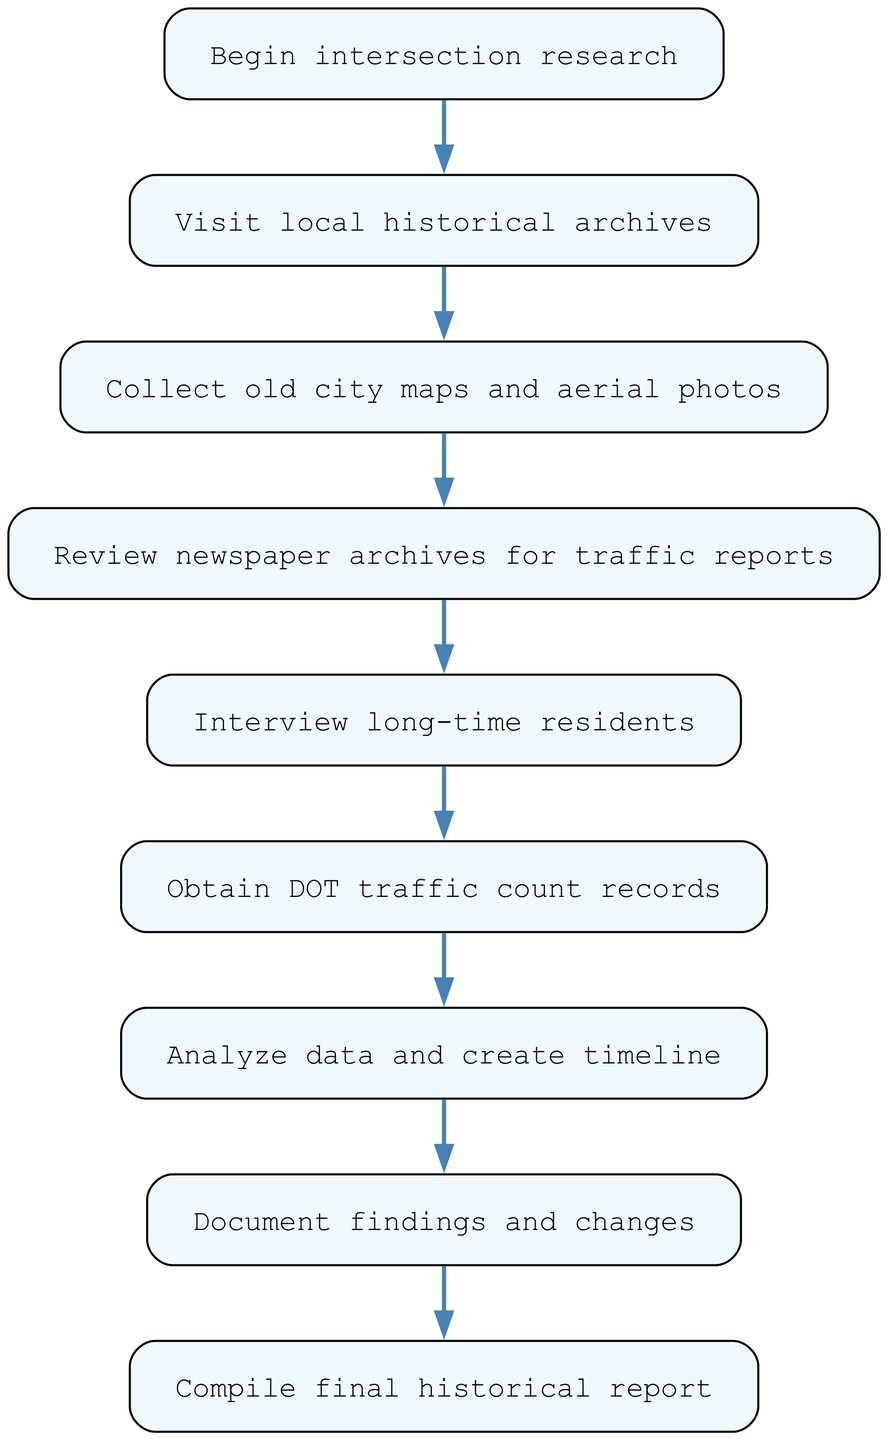What is the starting point of the research process? The starting point, or initial node in the flowchart, is labeled "Begin intersection research." This is the first action indicated in the diagram.
Answer: Begin intersection research How many nodes are in the flowchart? To count the nodes, we evaluate each unique action or decision point in the flowchart. There are a total of 9 nodes listed in the diagram.
Answer: 9 Which action follows the review of newspaper archives? After "Review newspaper archives for traffic reports," the next action indicated in the flowchart is to "Interview long-time residents." This shows the sequential flow from one step to the next.
Answer: Interview long-time residents What type of records are obtained after interviewing residents? Following the "Interview long-time residents" step, the next action is to "Obtain DOT traffic count records." This indicates the flow of information gathering from personal accounts to official records.
Answer: Obtain DOT traffic count records What is the last step in the flowchart? The last action listed in the flowchart is "Compile final historical report." This step concludes the entire research and documentation process.
Answer: Compile final historical report What is the relationship between analyzing data and documenting findings? The flowchart indicates that after the step "Analyze data and create timeline," the subsequent step is "Document findings and changes." This establishes a direct sequential relationship between analyzing and documenting.
Answer: Document findings and changes What is the fourth step in the entire procedure? By observing the order of actions in the flowchart, the fourth step is "Interview long-time residents." This positions it within the complete flow of the research process.
Answer: Interview long-time residents Which action comes before visiting local historical archives? The flowchart starts with "Begin intersection research," which is indicated as the action occurring before "Visit local historical archives". This shows the initial movement into research.
Answer: Begin intersection research 